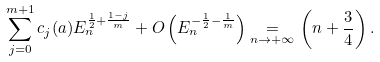<formula> <loc_0><loc_0><loc_500><loc_500>\sum _ { j = 0 } ^ { m + 1 } c _ { j } ( { a } ) E _ { n } ^ { \frac { 1 } { 2 } + \frac { 1 - j } { m } } + O \left ( E _ { n } ^ { - \frac { 1 } { 2 } - \frac { 1 } { m } } \right ) \underset { n \to + \infty } { = } \left ( n + \frac { 3 } { 4 } \right ) .</formula> 